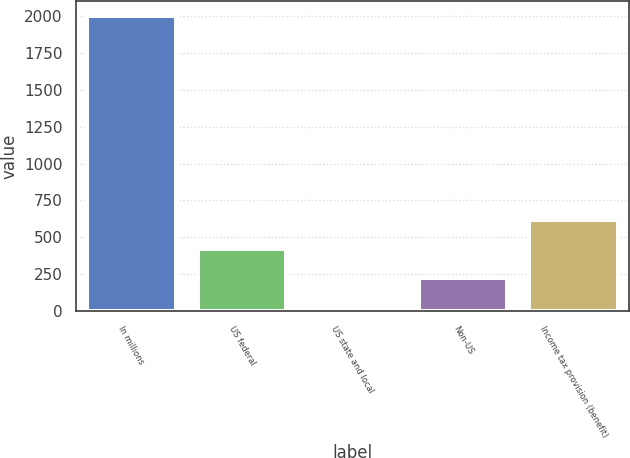<chart> <loc_0><loc_0><loc_500><loc_500><bar_chart><fcel>In millions<fcel>US federal<fcel>US state and local<fcel>Non-US<fcel>Income tax provision (benefit)<nl><fcel>2004<fcel>420<fcel>24<fcel>222<fcel>618<nl></chart> 